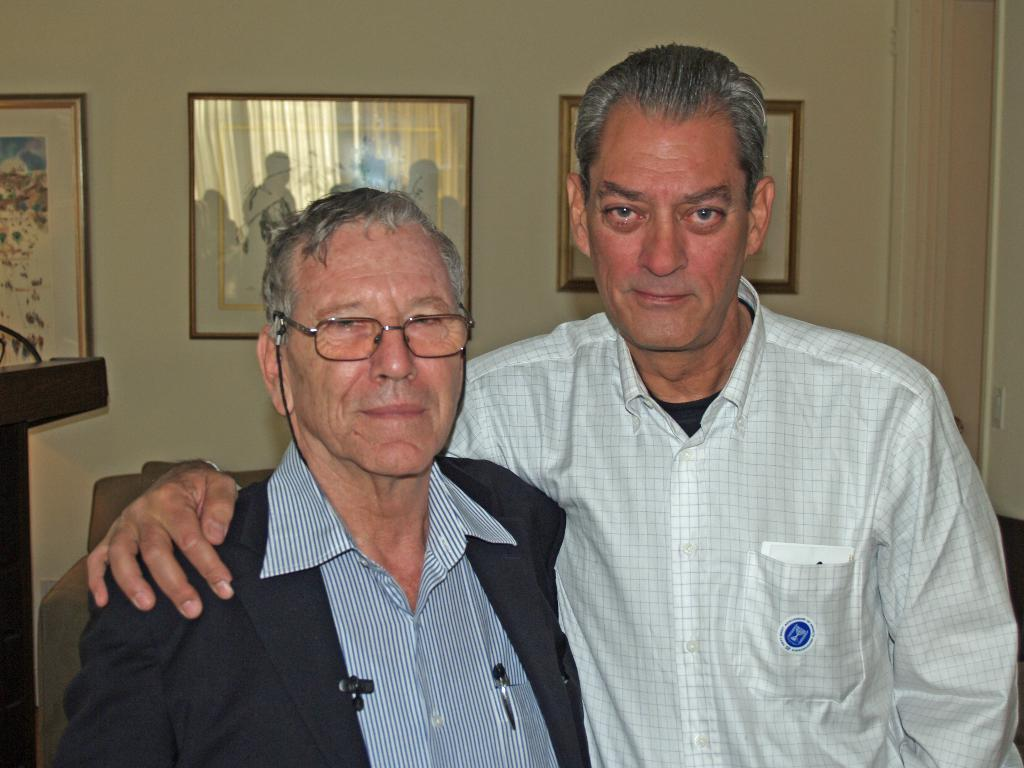How many people are in the image? There are two people standing in the image. What are the two people doing? The two people are posing for a photo. What can be seen in the background of the image? There is a couch and three photo frames on the wall in the background of the image. Is there any quicksand visible in the image? No, there is no quicksand present in the image. How many wrens can be seen in the photo frames on the wall? There are no wrens depicted in the photo frames on the wall; they contain images of people or other subjects. 